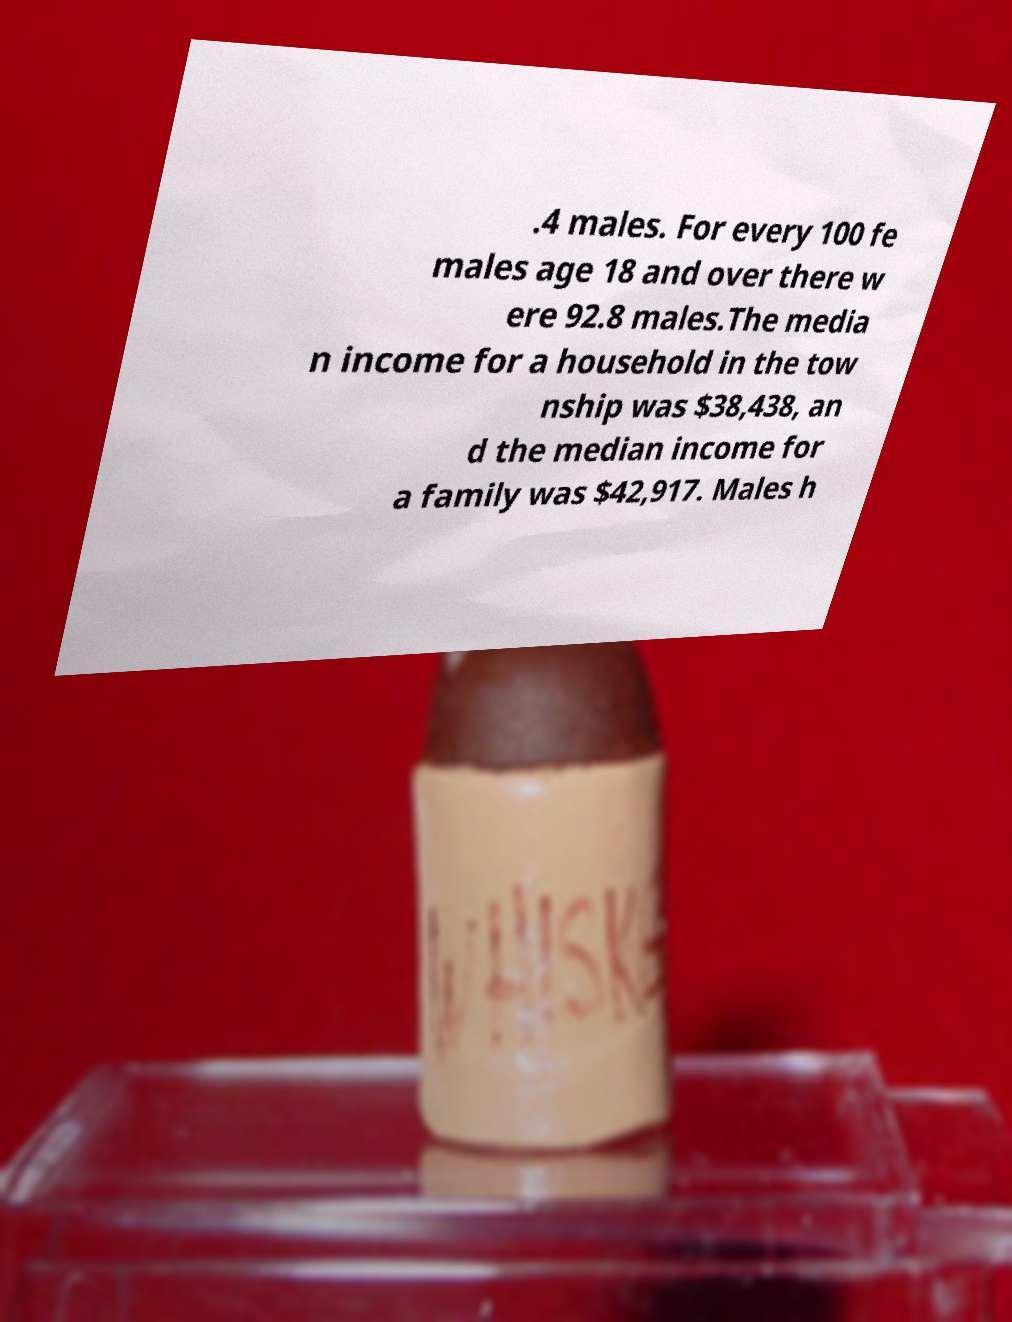Please read and relay the text visible in this image. What does it say? .4 males. For every 100 fe males age 18 and over there w ere 92.8 males.The media n income for a household in the tow nship was $38,438, an d the median income for a family was $42,917. Males h 